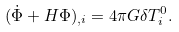<formula> <loc_0><loc_0><loc_500><loc_500>( \dot { \Phi } + H \Phi ) _ { , i } = 4 \pi G \delta T _ { i } ^ { 0 } .</formula> 